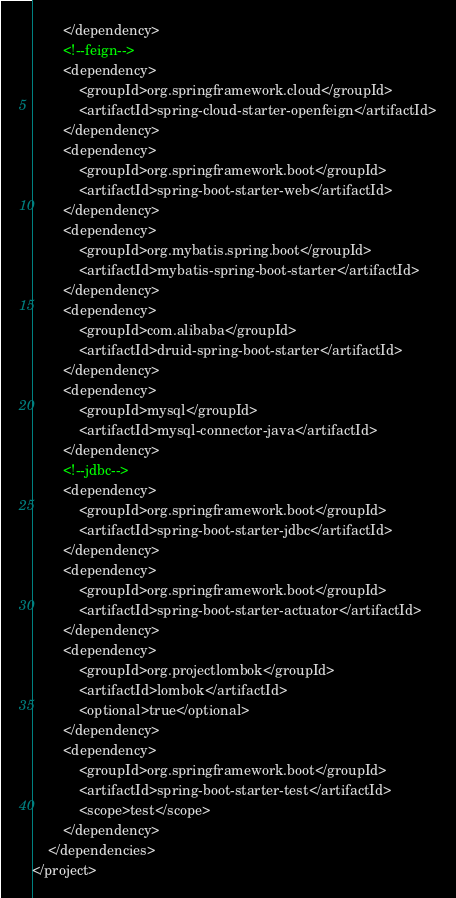<code> <loc_0><loc_0><loc_500><loc_500><_XML_>        </dependency>
        <!--feign-->
        <dependency>
            <groupId>org.springframework.cloud</groupId>
            <artifactId>spring-cloud-starter-openfeign</artifactId>
        </dependency>
        <dependency>
            <groupId>org.springframework.boot</groupId>
            <artifactId>spring-boot-starter-web</artifactId>
        </dependency>
        <dependency>
            <groupId>org.mybatis.spring.boot</groupId>
            <artifactId>mybatis-spring-boot-starter</artifactId>
        </dependency>
        <dependency>
            <groupId>com.alibaba</groupId>
            <artifactId>druid-spring-boot-starter</artifactId>
        </dependency>
        <dependency>
            <groupId>mysql</groupId>
            <artifactId>mysql-connector-java</artifactId>
        </dependency>
        <!--jdbc-->
        <dependency>
            <groupId>org.springframework.boot</groupId>
            <artifactId>spring-boot-starter-jdbc</artifactId>
        </dependency>
        <dependency>
            <groupId>org.springframework.boot</groupId>
            <artifactId>spring-boot-starter-actuator</artifactId>
        </dependency>
        <dependency>
            <groupId>org.projectlombok</groupId>
            <artifactId>lombok</artifactId>
            <optional>true</optional>
        </dependency>
        <dependency>
            <groupId>org.springframework.boot</groupId>
            <artifactId>spring-boot-starter-test</artifactId>
            <scope>test</scope>
        </dependency>
    </dependencies>
</project></code> 